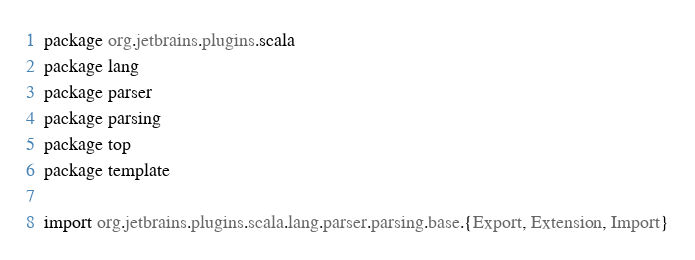<code> <loc_0><loc_0><loc_500><loc_500><_Scala_>package org.jetbrains.plugins.scala
package lang
package parser
package parsing
package top
package template

import org.jetbrains.plugins.scala.lang.parser.parsing.base.{Export, Extension, Import}</code> 